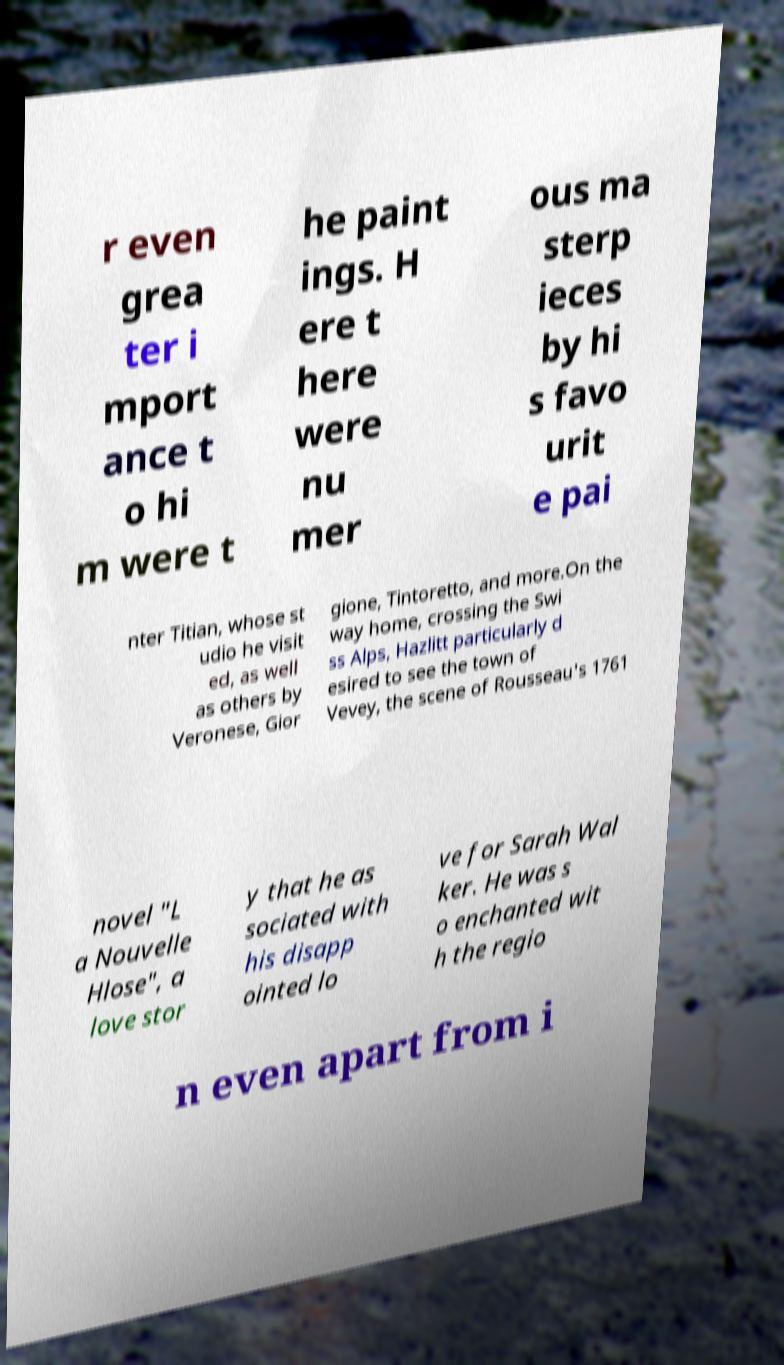There's text embedded in this image that I need extracted. Can you transcribe it verbatim? r even grea ter i mport ance t o hi m were t he paint ings. H ere t here were nu mer ous ma sterp ieces by hi s favo urit e pai nter Titian, whose st udio he visit ed, as well as others by Veronese, Gior gione, Tintoretto, and more.On the way home, crossing the Swi ss Alps, Hazlitt particularly d esired to see the town of Vevey, the scene of Rousseau's 1761 novel "L a Nouvelle Hlose", a love stor y that he as sociated with his disapp ointed lo ve for Sarah Wal ker. He was s o enchanted wit h the regio n even apart from i 